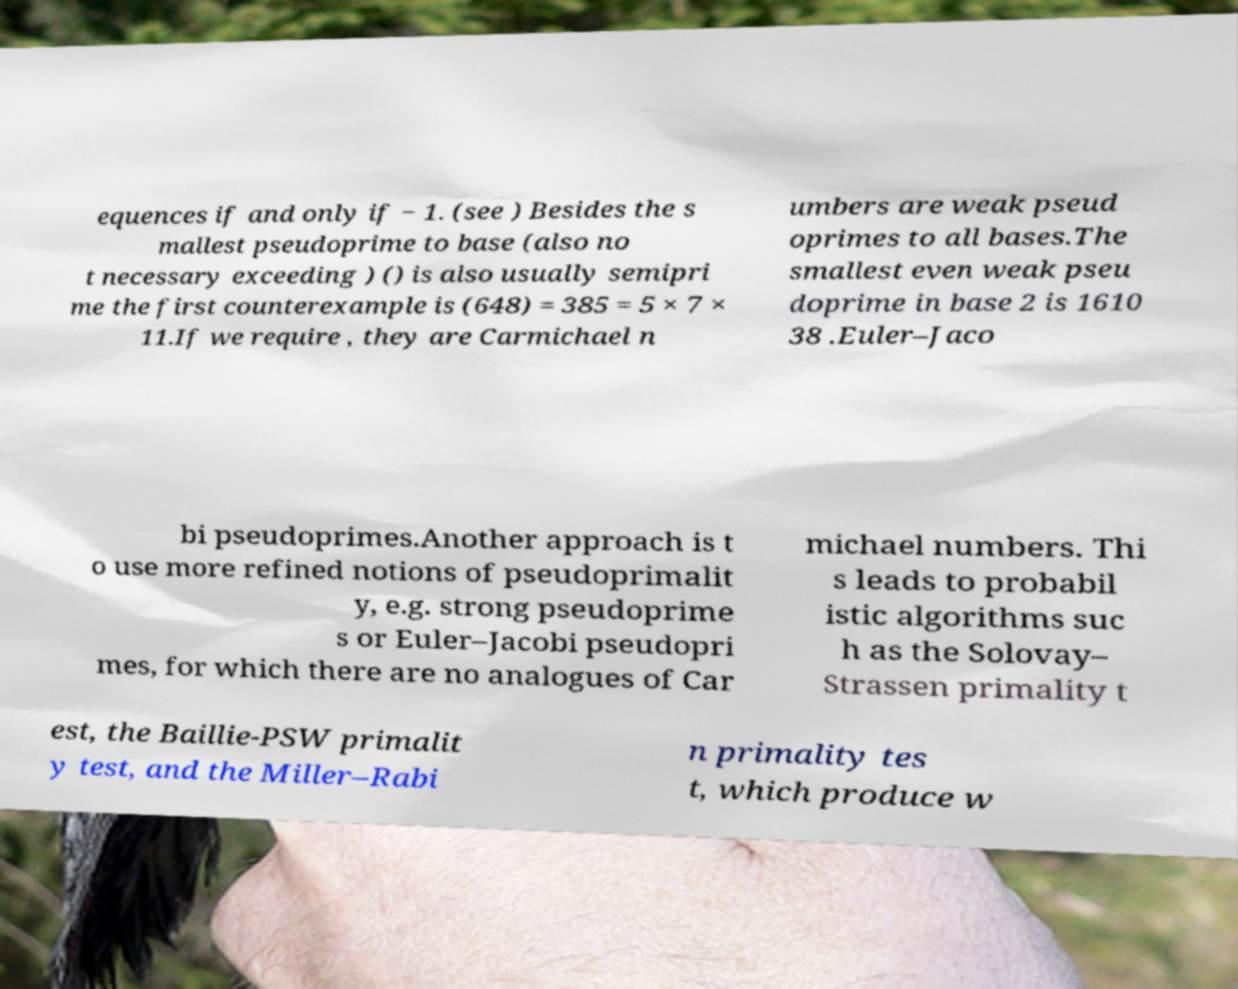For documentation purposes, I need the text within this image transcribed. Could you provide that? equences if and only if − 1. (see ) Besides the s mallest pseudoprime to base (also no t necessary exceeding ) () is also usually semipri me the first counterexample is (648) = 385 = 5 × 7 × 11.If we require , they are Carmichael n umbers are weak pseud oprimes to all bases.The smallest even weak pseu doprime in base 2 is 1610 38 .Euler–Jaco bi pseudoprimes.Another approach is t o use more refined notions of pseudoprimalit y, e.g. strong pseudoprime s or Euler–Jacobi pseudopri mes, for which there are no analogues of Car michael numbers. Thi s leads to probabil istic algorithms suc h as the Solovay– Strassen primality t est, the Baillie-PSW primalit y test, and the Miller–Rabi n primality tes t, which produce w 